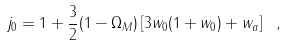Convert formula to latex. <formula><loc_0><loc_0><loc_500><loc_500>j _ { 0 } = 1 + \frac { 3 } { 2 } ( 1 - \Omega _ { M } ) \left [ 3 w _ { 0 } ( 1 + w _ { 0 } ) + w _ { a } \right ] \ ,</formula> 